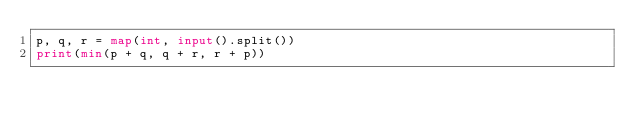<code> <loc_0><loc_0><loc_500><loc_500><_Python_>p, q, r = map(int, input().split())
print(min(p + q, q + r, r + p))</code> 